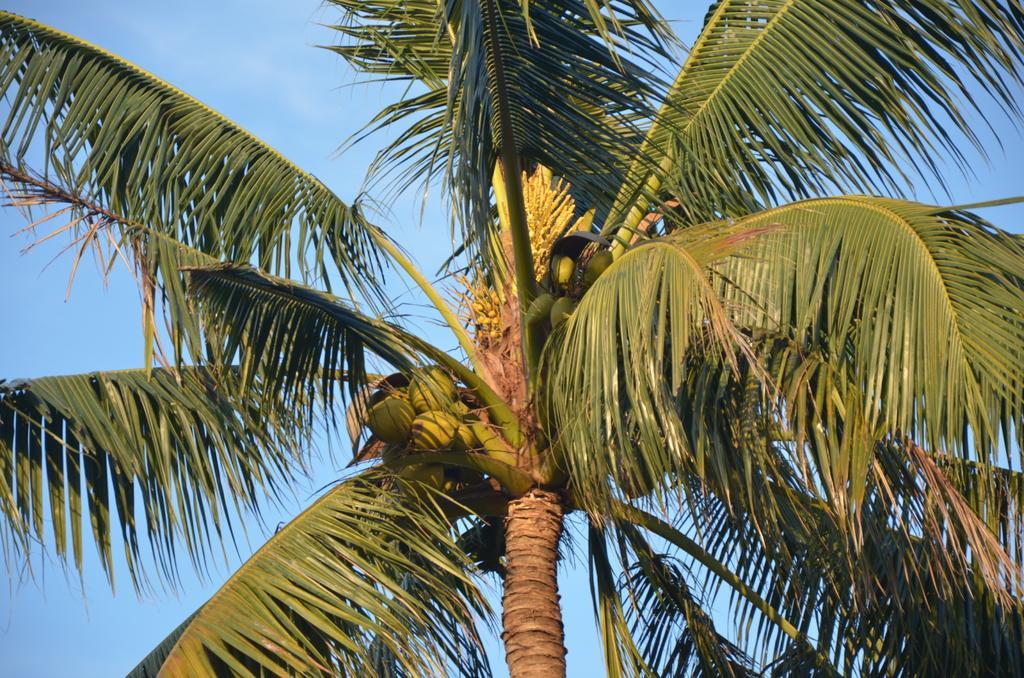Describe this image in one or two sentences. In this image I can see the tree and few coconuts to it. The sky is in blue color. 